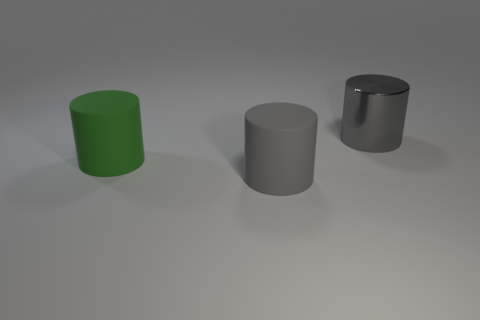Is the number of green matte cylinders less than the number of large matte objects?
Your answer should be compact. Yes. What is the color of the cylinder on the right side of the large gray cylinder that is in front of the large green thing?
Give a very brief answer. Gray. What is the material of the large cylinder on the right side of the gray matte object in front of the large cylinder that is right of the big gray matte thing?
Ensure brevity in your answer.  Metal. There is a object that is to the right of the gray matte thing; is it the same size as the large green thing?
Give a very brief answer. Yes. There is a big cylinder that is in front of the big green matte object; what is its material?
Make the answer very short. Rubber. Are there more gray matte objects than rubber cylinders?
Your answer should be very brief. No. How many objects are big cylinders that are on the left side of the large metallic thing or cylinders?
Your response must be concise. 3. What number of green matte cylinders are behind the large gray cylinder that is on the left side of the large gray shiny object?
Ensure brevity in your answer.  1. What size is the gray object in front of the large gray cylinder that is behind the large rubber object in front of the green cylinder?
Keep it short and to the point. Large. There is a big matte object that is in front of the big green matte cylinder; does it have the same color as the large shiny object?
Provide a short and direct response. Yes. 